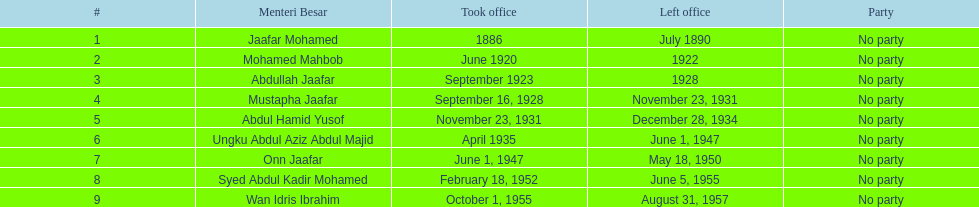What is the number of menteri besars that there have been during the pre-independence period? 9. 